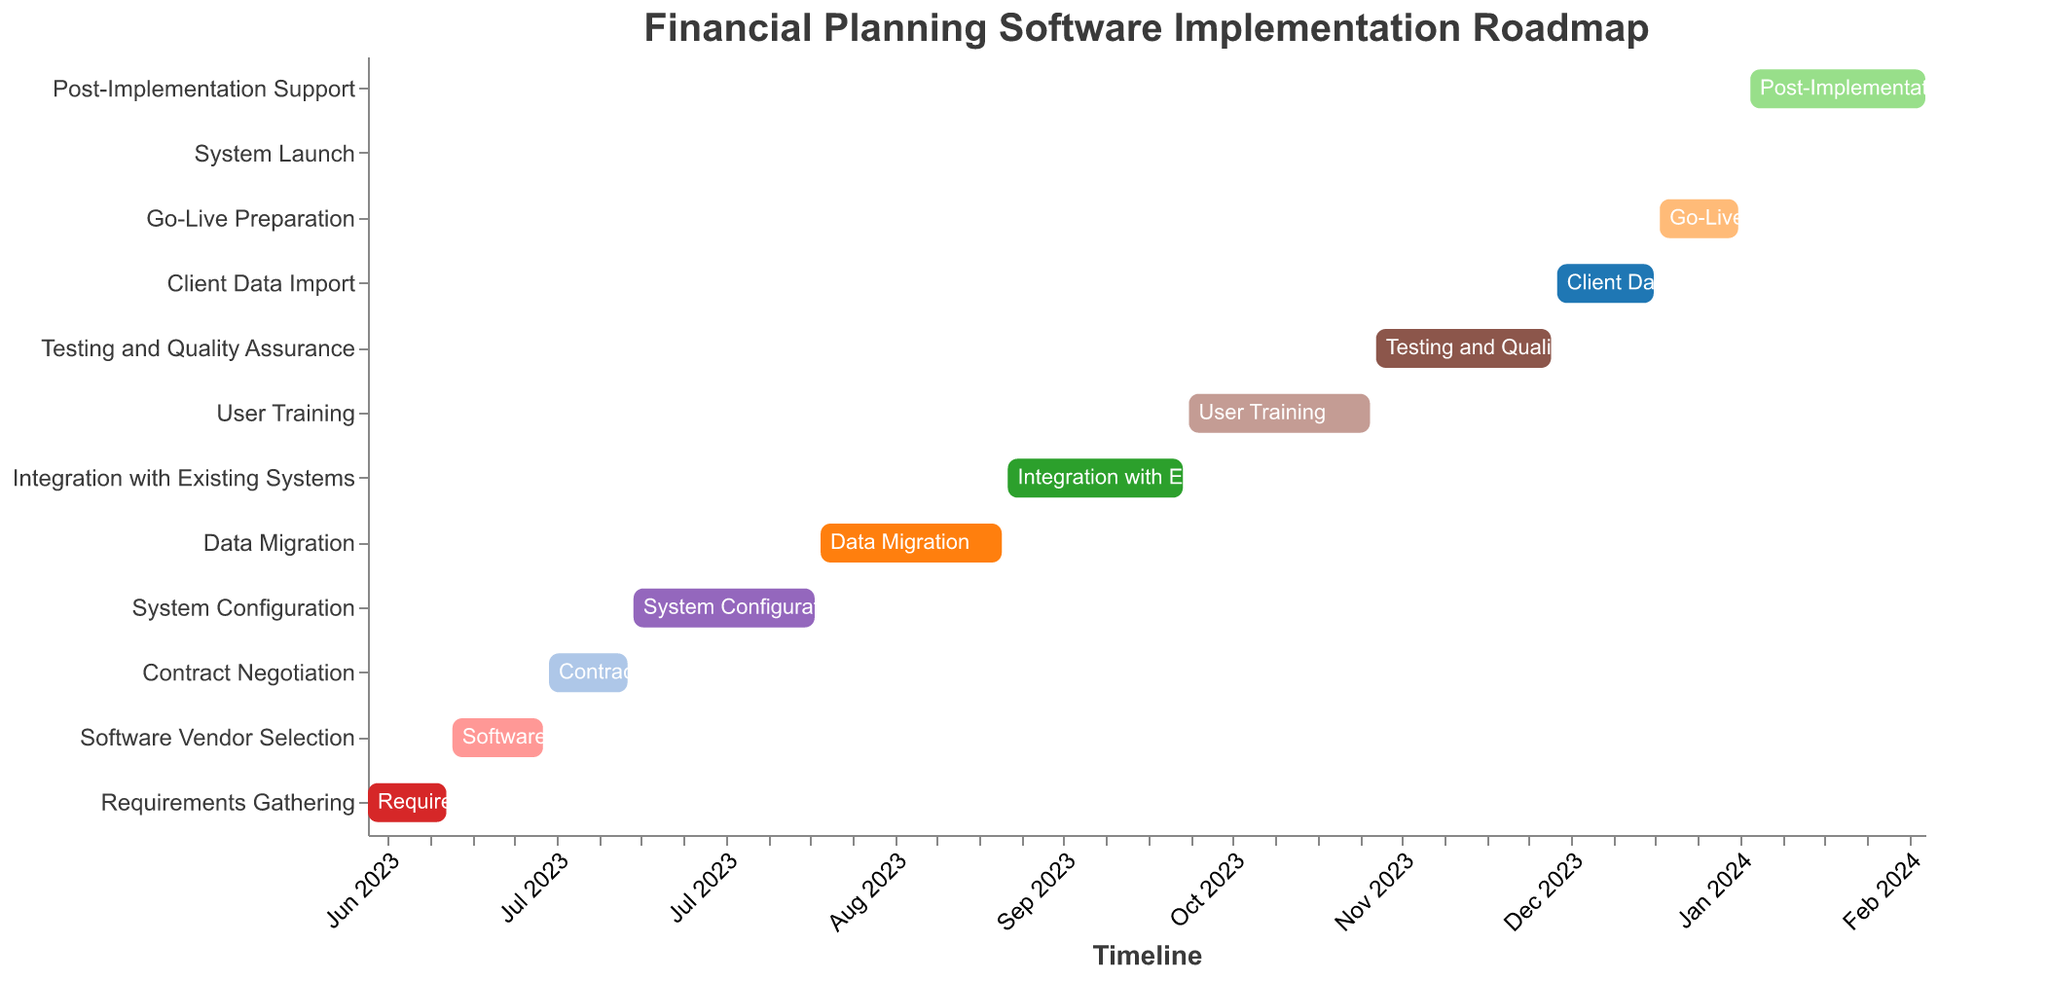What is the title of the chart? The title is found at the top of the chart, indicating what the chart represents.
Answer: Financial Planning Software Implementation Roadmap When does the 'Data Migration' task start and end? Look at the bar labeled 'Data Migration' to see the start and end dates. The start date is '2023-08-15' and the end date is '2023-09-14'.
Answer: Aug 15, 2023 to Sep 14, 2023 Which tasks have the same duration of 31 days? Locate the tasks with bars of the same length labeled '31' in the 'Duration' column. These are 'System Configuration', 'Data Migration', and 'User Training'.
Answer: System Configuration, Data Migration, User Training How many tasks have a duration of less than 30 days? Identify tasks with a 'Duration' value below 30 days by counting these tasks. The durations of such tasks are 14, 16, 14, 17, 14, and 1 days.
Answer: 6 Which task has the shortest duration and when does it occur? Find the bar with the label that shows a duration of '1'. This bar belongs to 'System Launch,' which occurs on '2024-01-15'.
Answer: System Launch, Jan 15, 2024 Compare the start dates of 'Requirements Gathering' and 'Testing and Quality Assurance'. Which one starts earlier and by how many months? Look at the start dates of 'Requirements Gathering' (Jun 1, 2023) and 'Testing and Quality Assurance' (Nov 15, 2023). 'Requirements Gathering' starts earlier—find the difference in months between June and November.
Answer: Requirements Gathering, 5 months What is the total duration of 'Post-Implementation Support' and 'Go-Live Preparation'? Add the durations of 'Post-Implementation Support' (30 days) and 'Go-Live Preparation' (14 days).
Answer: 44 days Which tasks overlap with 'System Configuration'? 'System Configuration' runs from '2023-07-15' to '2023-08-14'. Tasks overlapping this period are 'Contract Negotiation' (ends on '2023-07-14') and 'Data Migration' (starts on '2023-08-15').
Answer: None overlapping What is the duration between the start of 'Contract Negotiation' and the start of 'Integration with Existing Systems'? The start date of 'Contract Negotiation' is '2023-07-01' and for 'Integration with Existing Systems' is '2023-09-15'. Calculate the days between these two dates.
Answer: 76 days Which task immediately follows 'Testing and Quality Assurance'? The task right after 'Testing and Quality Assurance', which ends on '2023-12-14', is 'Client Data Import' starting on '2023-12-15'.
Answer: Client Data Import 